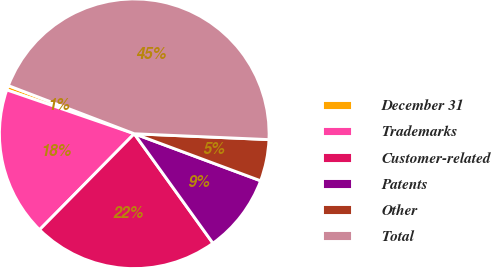Convert chart to OTSL. <chart><loc_0><loc_0><loc_500><loc_500><pie_chart><fcel>December 31<fcel>Trademarks<fcel>Customer-related<fcel>Patents<fcel>Other<fcel>Total<nl><fcel>0.54%<fcel>17.88%<fcel>22.31%<fcel>9.41%<fcel>4.98%<fcel>44.88%<nl></chart> 